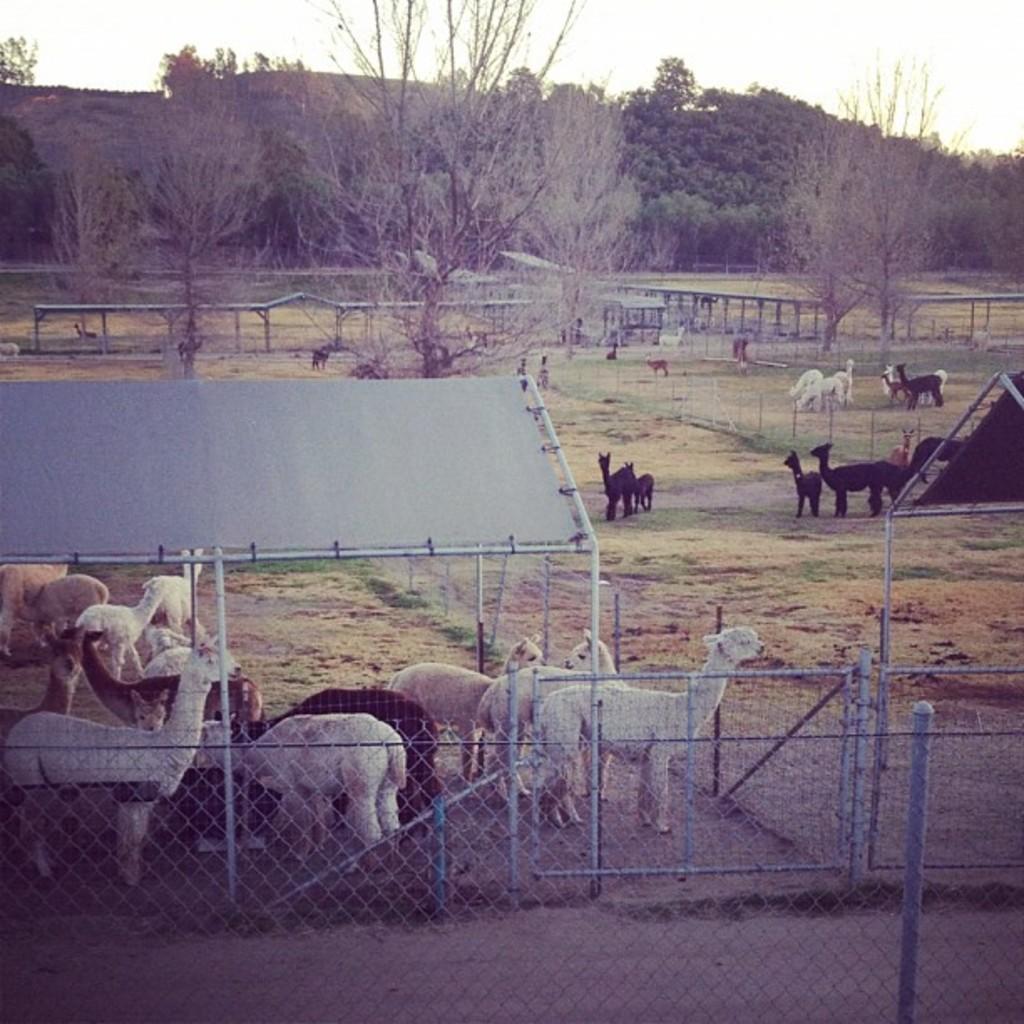Could you give a brief overview of what you see in this image? In this picture we can see a few animals on the path. There is some fencing from left to right. We can see some trees in the background. 